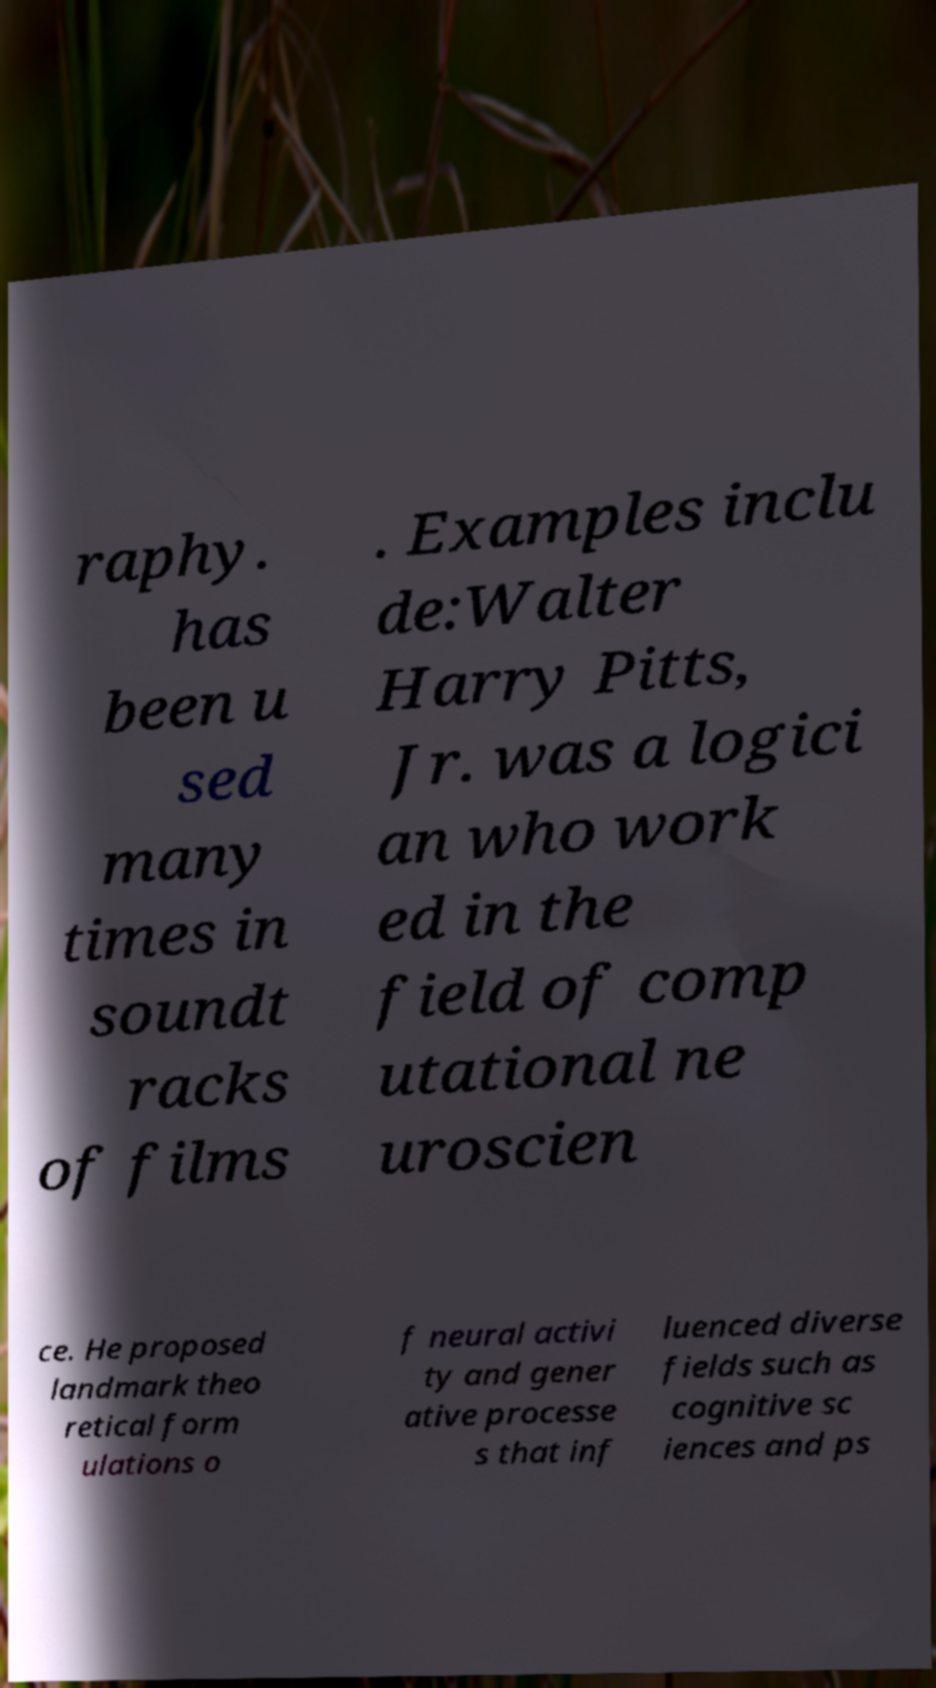For documentation purposes, I need the text within this image transcribed. Could you provide that? raphy. has been u sed many times in soundt racks of films . Examples inclu de:Walter Harry Pitts, Jr. was a logici an who work ed in the field of comp utational ne uroscien ce. He proposed landmark theo retical form ulations o f neural activi ty and gener ative processe s that inf luenced diverse fields such as cognitive sc iences and ps 